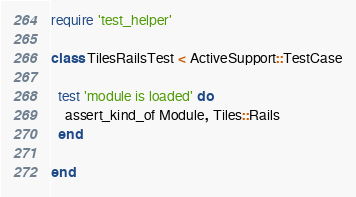<code> <loc_0><loc_0><loc_500><loc_500><_Ruby_>require 'test_helper'

class TilesRailsTest < ActiveSupport::TestCase

  test 'module is loaded' do
    assert_kind_of Module, Tiles::Rails
  end

end
</code> 